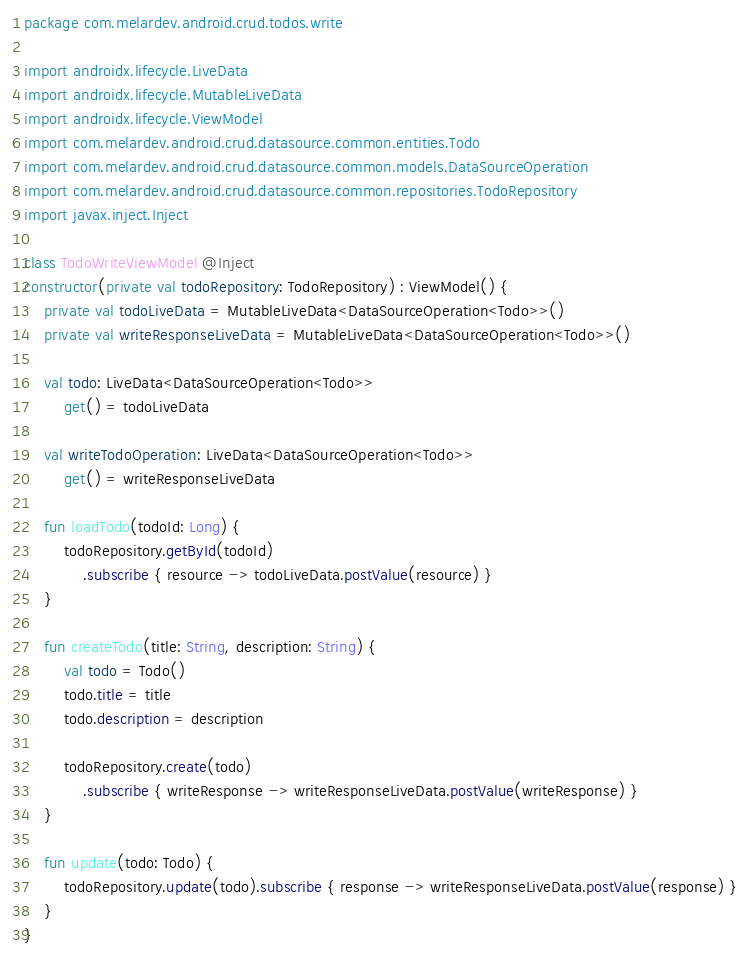<code> <loc_0><loc_0><loc_500><loc_500><_Kotlin_>package com.melardev.android.crud.todos.write

import androidx.lifecycle.LiveData
import androidx.lifecycle.MutableLiveData
import androidx.lifecycle.ViewModel
import com.melardev.android.crud.datasource.common.entities.Todo
import com.melardev.android.crud.datasource.common.models.DataSourceOperation
import com.melardev.android.crud.datasource.common.repositories.TodoRepository
import javax.inject.Inject

class TodoWriteViewModel @Inject
constructor(private val todoRepository: TodoRepository) : ViewModel() {
    private val todoLiveData = MutableLiveData<DataSourceOperation<Todo>>()
    private val writeResponseLiveData = MutableLiveData<DataSourceOperation<Todo>>()

    val todo: LiveData<DataSourceOperation<Todo>>
        get() = todoLiveData

    val writeTodoOperation: LiveData<DataSourceOperation<Todo>>
        get() = writeResponseLiveData

    fun loadTodo(todoId: Long) {
        todoRepository.getById(todoId)
            .subscribe { resource -> todoLiveData.postValue(resource) }
    }

    fun createTodo(title: String, description: String) {
        val todo = Todo()
        todo.title = title
        todo.description = description

        todoRepository.create(todo)
            .subscribe { writeResponse -> writeResponseLiveData.postValue(writeResponse) }
    }

    fun update(todo: Todo) {
        todoRepository.update(todo).subscribe { response -> writeResponseLiveData.postValue(response) }
    }
}
</code> 